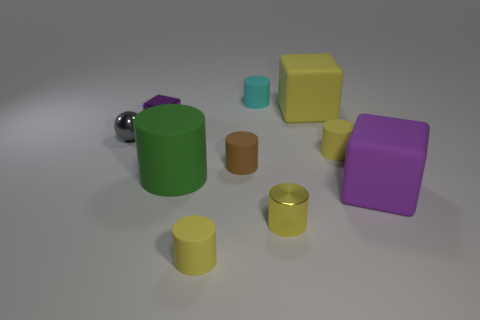Subtract all brown cubes. How many yellow cylinders are left? 3 Subtract all green cylinders. How many cylinders are left? 5 Subtract all large green cylinders. How many cylinders are left? 5 Subtract all gray cylinders. Subtract all yellow spheres. How many cylinders are left? 6 Subtract all cylinders. How many objects are left? 4 Add 9 large green matte objects. How many large green matte objects exist? 10 Subtract 0 red cubes. How many objects are left? 10 Subtract all purple matte cylinders. Subtract all small gray spheres. How many objects are left? 9 Add 5 cyan matte cylinders. How many cyan matte cylinders are left? 6 